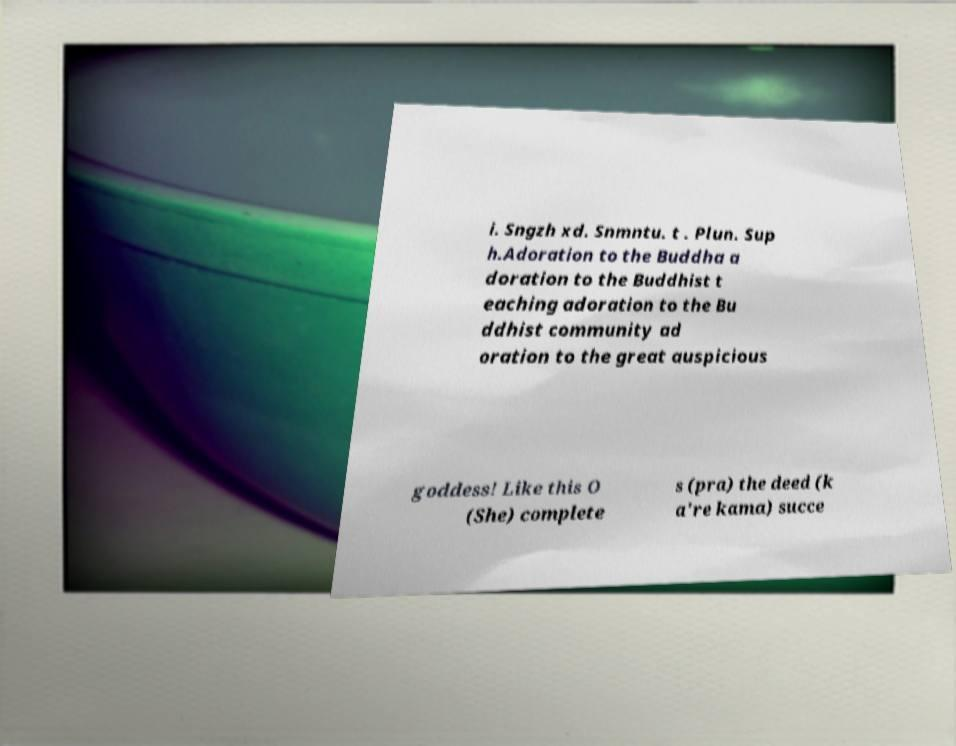There's text embedded in this image that I need extracted. Can you transcribe it verbatim? i. Sngzh xd. Snmntu. t . Plun. Sup h.Adoration to the Buddha a doration to the Buddhist t eaching adoration to the Bu ddhist community ad oration to the great auspicious goddess! Like this O (She) complete s (pra) the deed (k a're kama) succe 